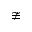Convert formula to latex. <formula><loc_0><loc_0><loc_500><loc_500>\ncong</formula> 